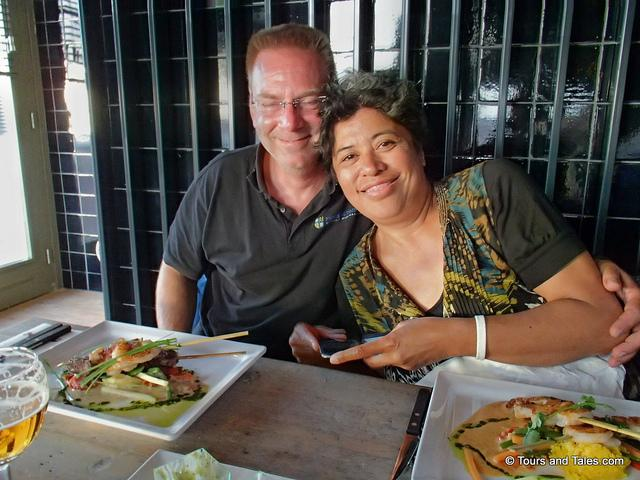How is the man's sight without assistance?

Choices:
A) colorblind
B) blind
C) perfect
D) impaired impaired 